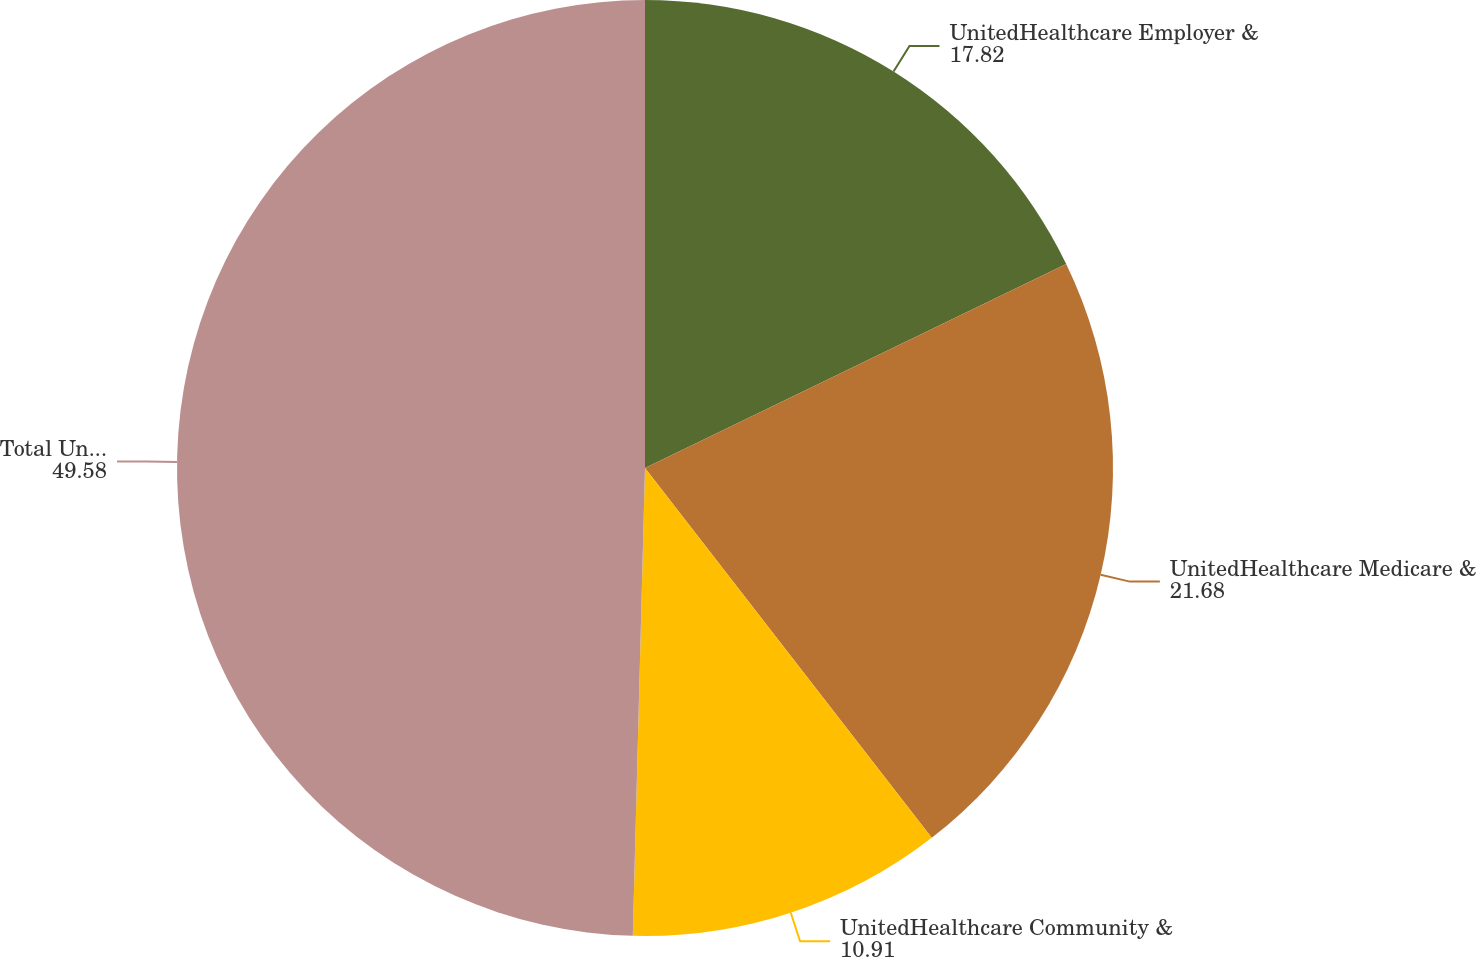Convert chart. <chart><loc_0><loc_0><loc_500><loc_500><pie_chart><fcel>UnitedHealthcare Employer &<fcel>UnitedHealthcare Medicare &<fcel>UnitedHealthcare Community &<fcel>Total UnitedHealthcare<nl><fcel>17.82%<fcel>21.68%<fcel>10.91%<fcel>49.58%<nl></chart> 